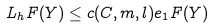<formula> <loc_0><loc_0><loc_500><loc_500>L _ { h } F ( Y ) \leq c ( C , m , l ) e _ { 1 } F ( Y )</formula> 